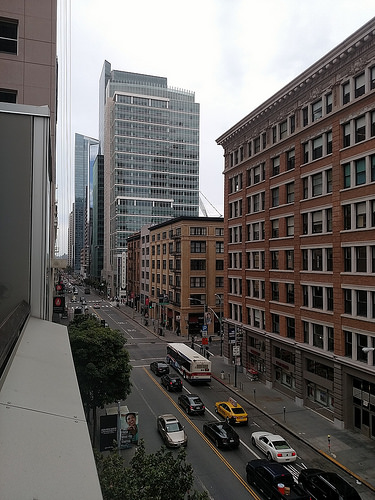<image>
Is the building behind the car? Yes. From this viewpoint, the building is positioned behind the car, with the car partially or fully occluding the building. 